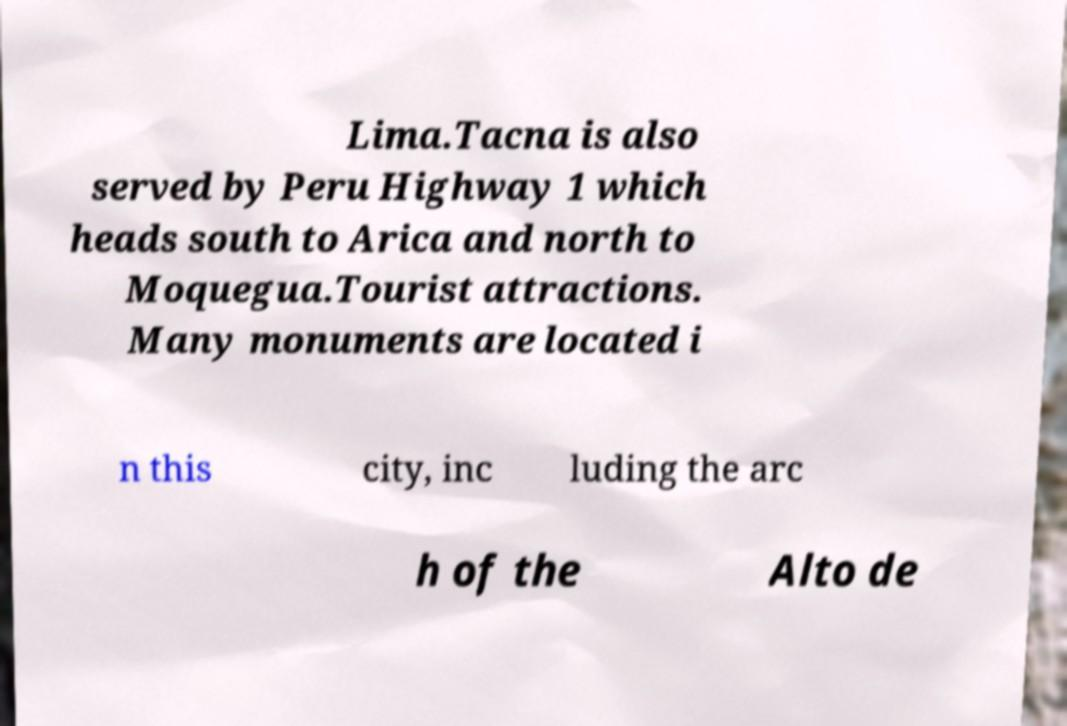For documentation purposes, I need the text within this image transcribed. Could you provide that? Lima.Tacna is also served by Peru Highway 1 which heads south to Arica and north to Moquegua.Tourist attractions. Many monuments are located i n this city, inc luding the arc h of the Alto de 